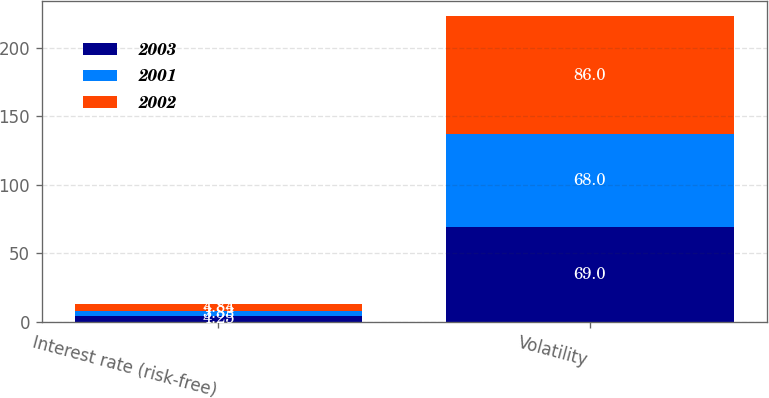Convert chart. <chart><loc_0><loc_0><loc_500><loc_500><stacked_bar_chart><ecel><fcel>Interest rate (risk-free)<fcel>Volatility<nl><fcel>2003<fcel>4.25<fcel>69<nl><fcel>2001<fcel>3.83<fcel>68<nl><fcel>2002<fcel>4.84<fcel>86<nl></chart> 